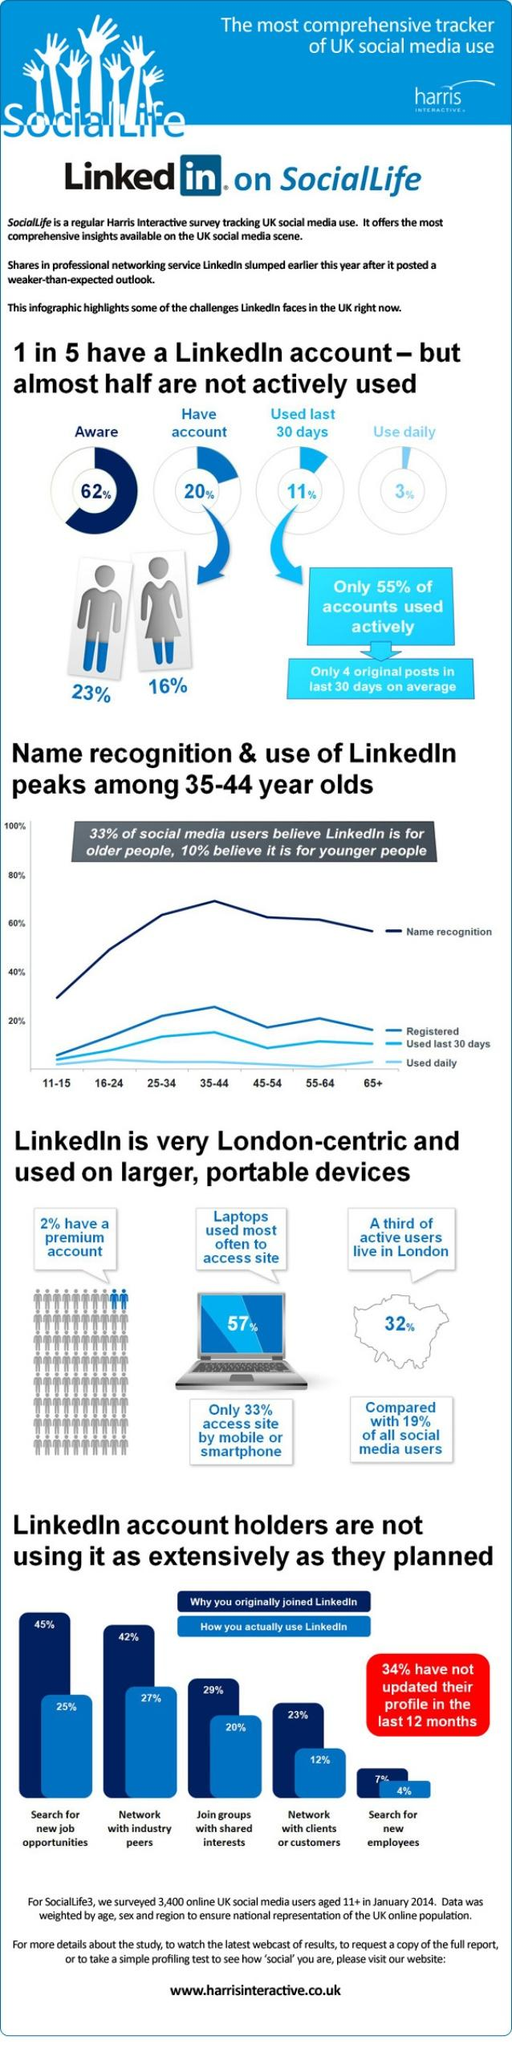Indicate a few pertinent items in this graphic. According to data, the percentage of men who have a LinkedIn account is approximately 7%, while the percentage of women who have a LinkedIn account is also 7%. The highest percentage of users on LinkedIn have joined to search for new job opportunities. According to a survey conducted on LinkedIn, 97% of the users do not use the platform on a daily basis. According to a recent survey, 32% of users from London use LinkedIn regularly. According to data, a significant 57% of users use LinkedIn through laptops. 